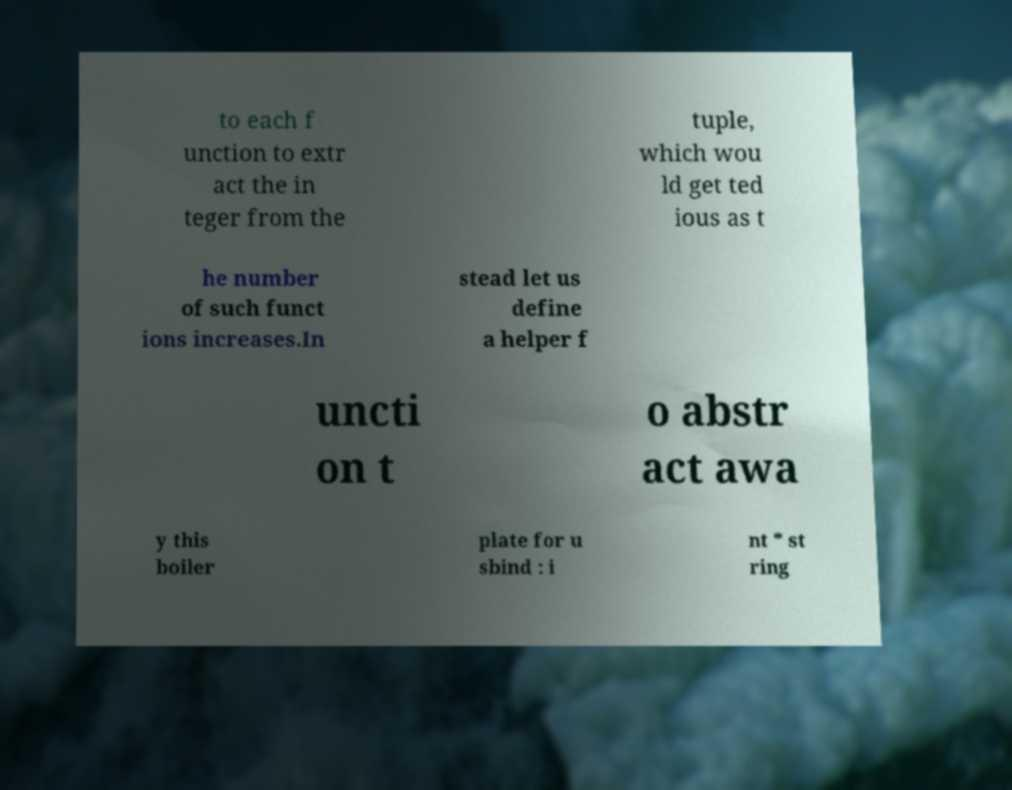What messages or text are displayed in this image? I need them in a readable, typed format. to each f unction to extr act the in teger from the tuple, which wou ld get ted ious as t he number of such funct ions increases.In stead let us define a helper f uncti on t o abstr act awa y this boiler plate for u sbind : i nt * st ring 